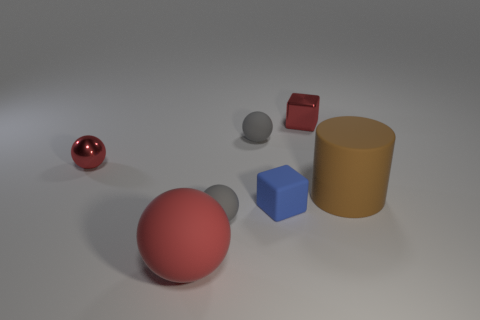Do the small shiny thing that is to the left of the red shiny block and the large ball have the same color?
Provide a succinct answer. Yes. Is there a metallic block that has the same color as the metal ball?
Give a very brief answer. Yes. How many other objects are there of the same material as the big red ball?
Make the answer very short. 4. There is a gray object that is in front of the metallic ball; is there a blue rubber cube that is on the right side of it?
Your answer should be very brief. Yes. Is there anything else that has the same shape as the brown rubber object?
Give a very brief answer. No. The other thing that is the same shape as the small blue matte thing is what color?
Keep it short and to the point. Red. What is the size of the brown matte object?
Make the answer very short. Large. Is the number of large red spheres right of the red metal block less than the number of gray rubber objects?
Provide a short and direct response. Yes. Is the material of the large brown object the same as the blue cube to the left of the large brown cylinder?
Give a very brief answer. Yes. There is a red metallic object right of the large rubber thing on the left side of the brown rubber cylinder; is there a object that is on the right side of it?
Provide a succinct answer. Yes. 